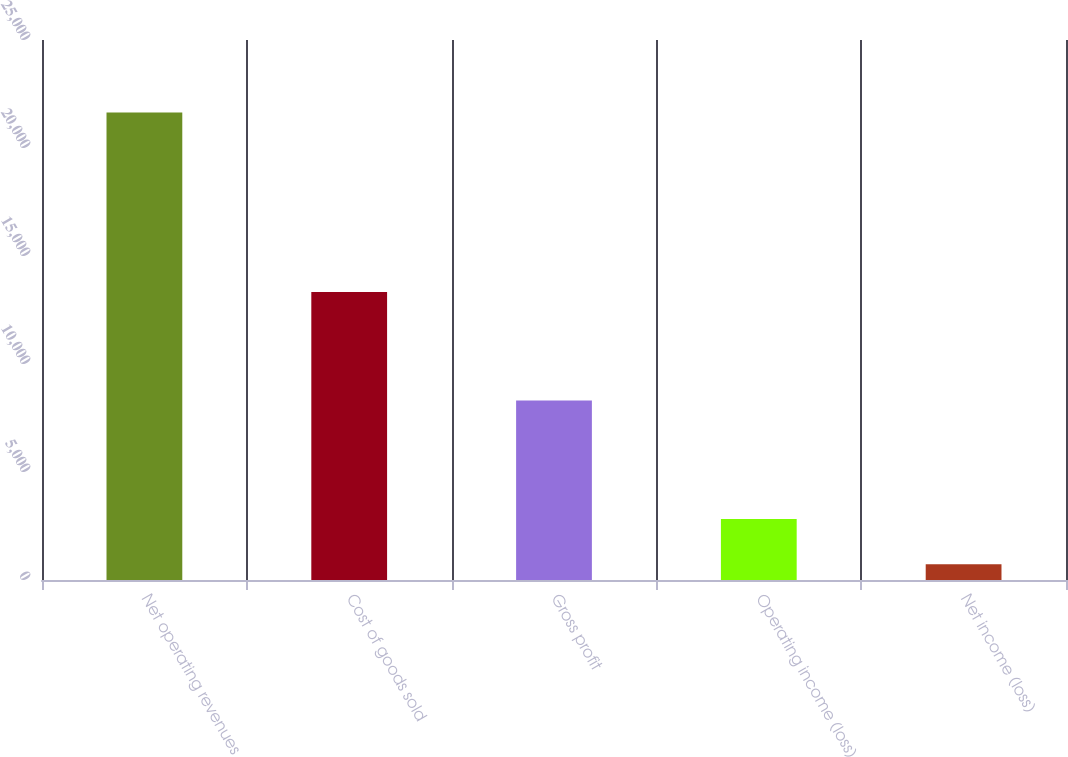<chart> <loc_0><loc_0><loc_500><loc_500><bar_chart><fcel>Net operating revenues<fcel>Cost of goods sold<fcel>Gross profit<fcel>Operating income (loss)<fcel>Net income (loss)<nl><fcel>21645<fcel>13333<fcel>8312<fcel>2822.4<fcel>731<nl></chart> 